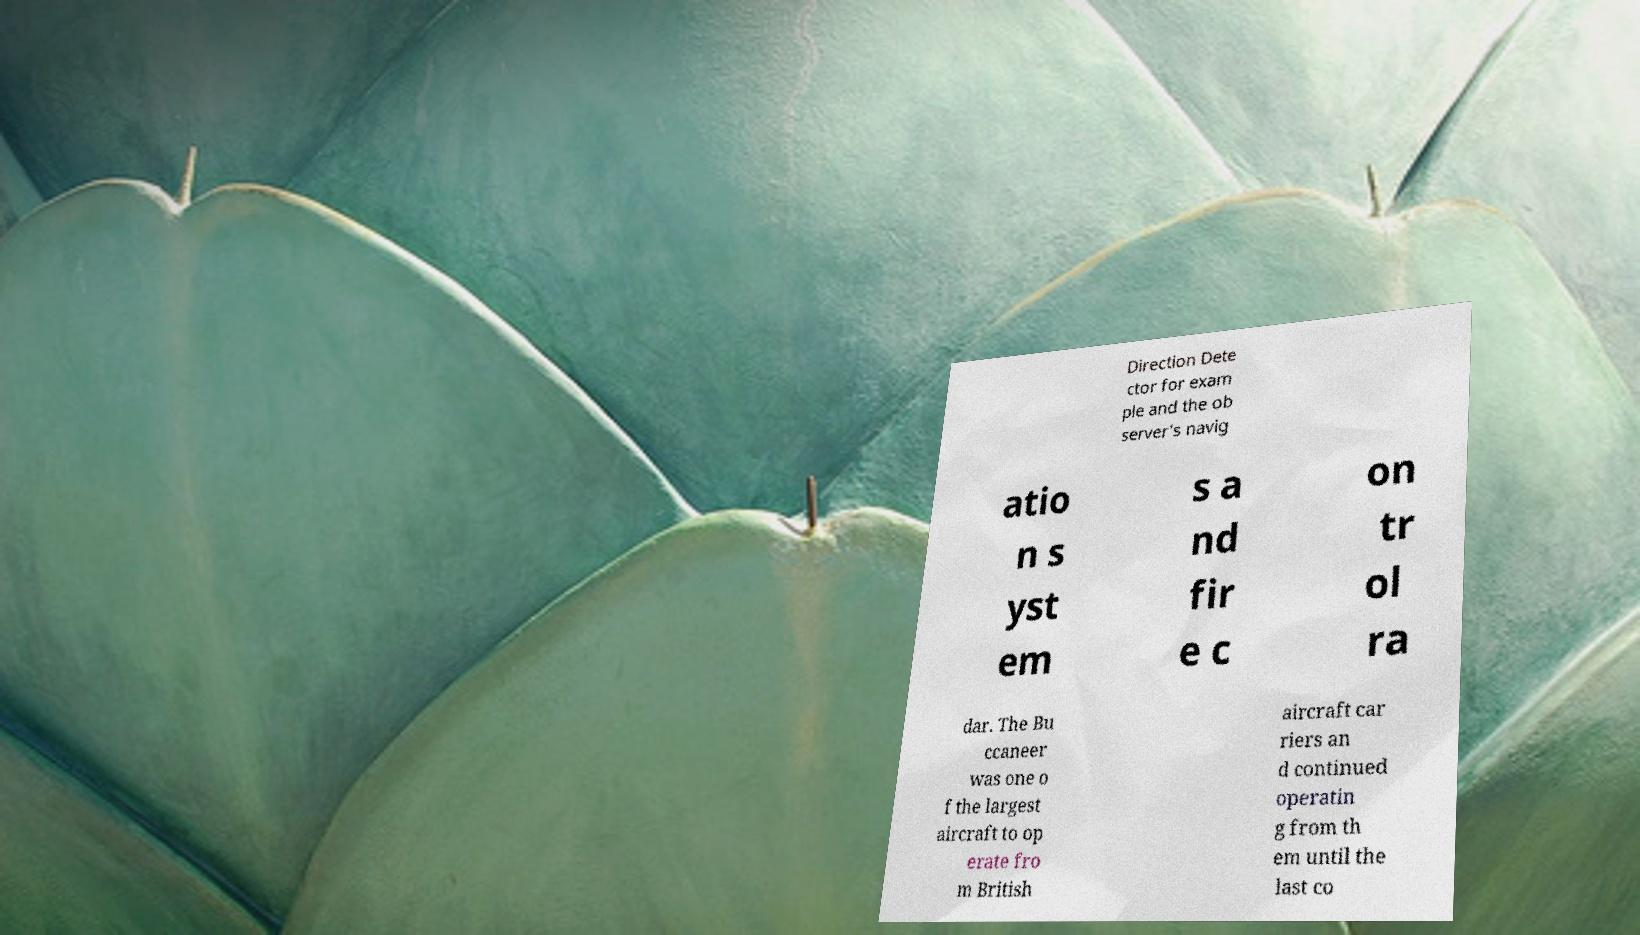Could you assist in decoding the text presented in this image and type it out clearly? Direction Dete ctor for exam ple and the ob server's navig atio n s yst em s a nd fir e c on tr ol ra dar. The Bu ccaneer was one o f the largest aircraft to op erate fro m British aircraft car riers an d continued operatin g from th em until the last co 